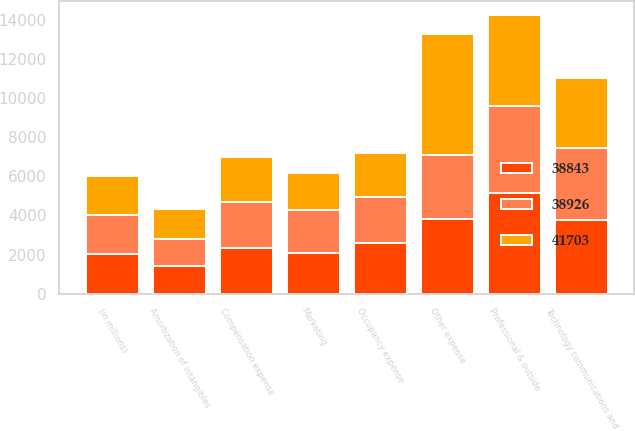Convert chart. <chart><loc_0><loc_0><loc_500><loc_500><stacked_bar_chart><ecel><fcel>(in millions)<fcel>Compensation expense<fcel>Occupancy expense<fcel>Technology communications and<fcel>Professional & outside<fcel>Marketing<fcel>Other expense<fcel>Amortization of intangibles<nl><fcel>38843<fcel>2007<fcel>2335<fcel>2608<fcel>3779<fcel>5140<fcel>2070<fcel>3814<fcel>1394<nl><fcel>38926<fcel>2006<fcel>2335<fcel>2335<fcel>3653<fcel>4450<fcel>2209<fcel>3272<fcel>1428<nl><fcel>41703<fcel>2005<fcel>2335<fcel>2269<fcel>3602<fcel>4662<fcel>1917<fcel>6199<fcel>1490<nl></chart> 